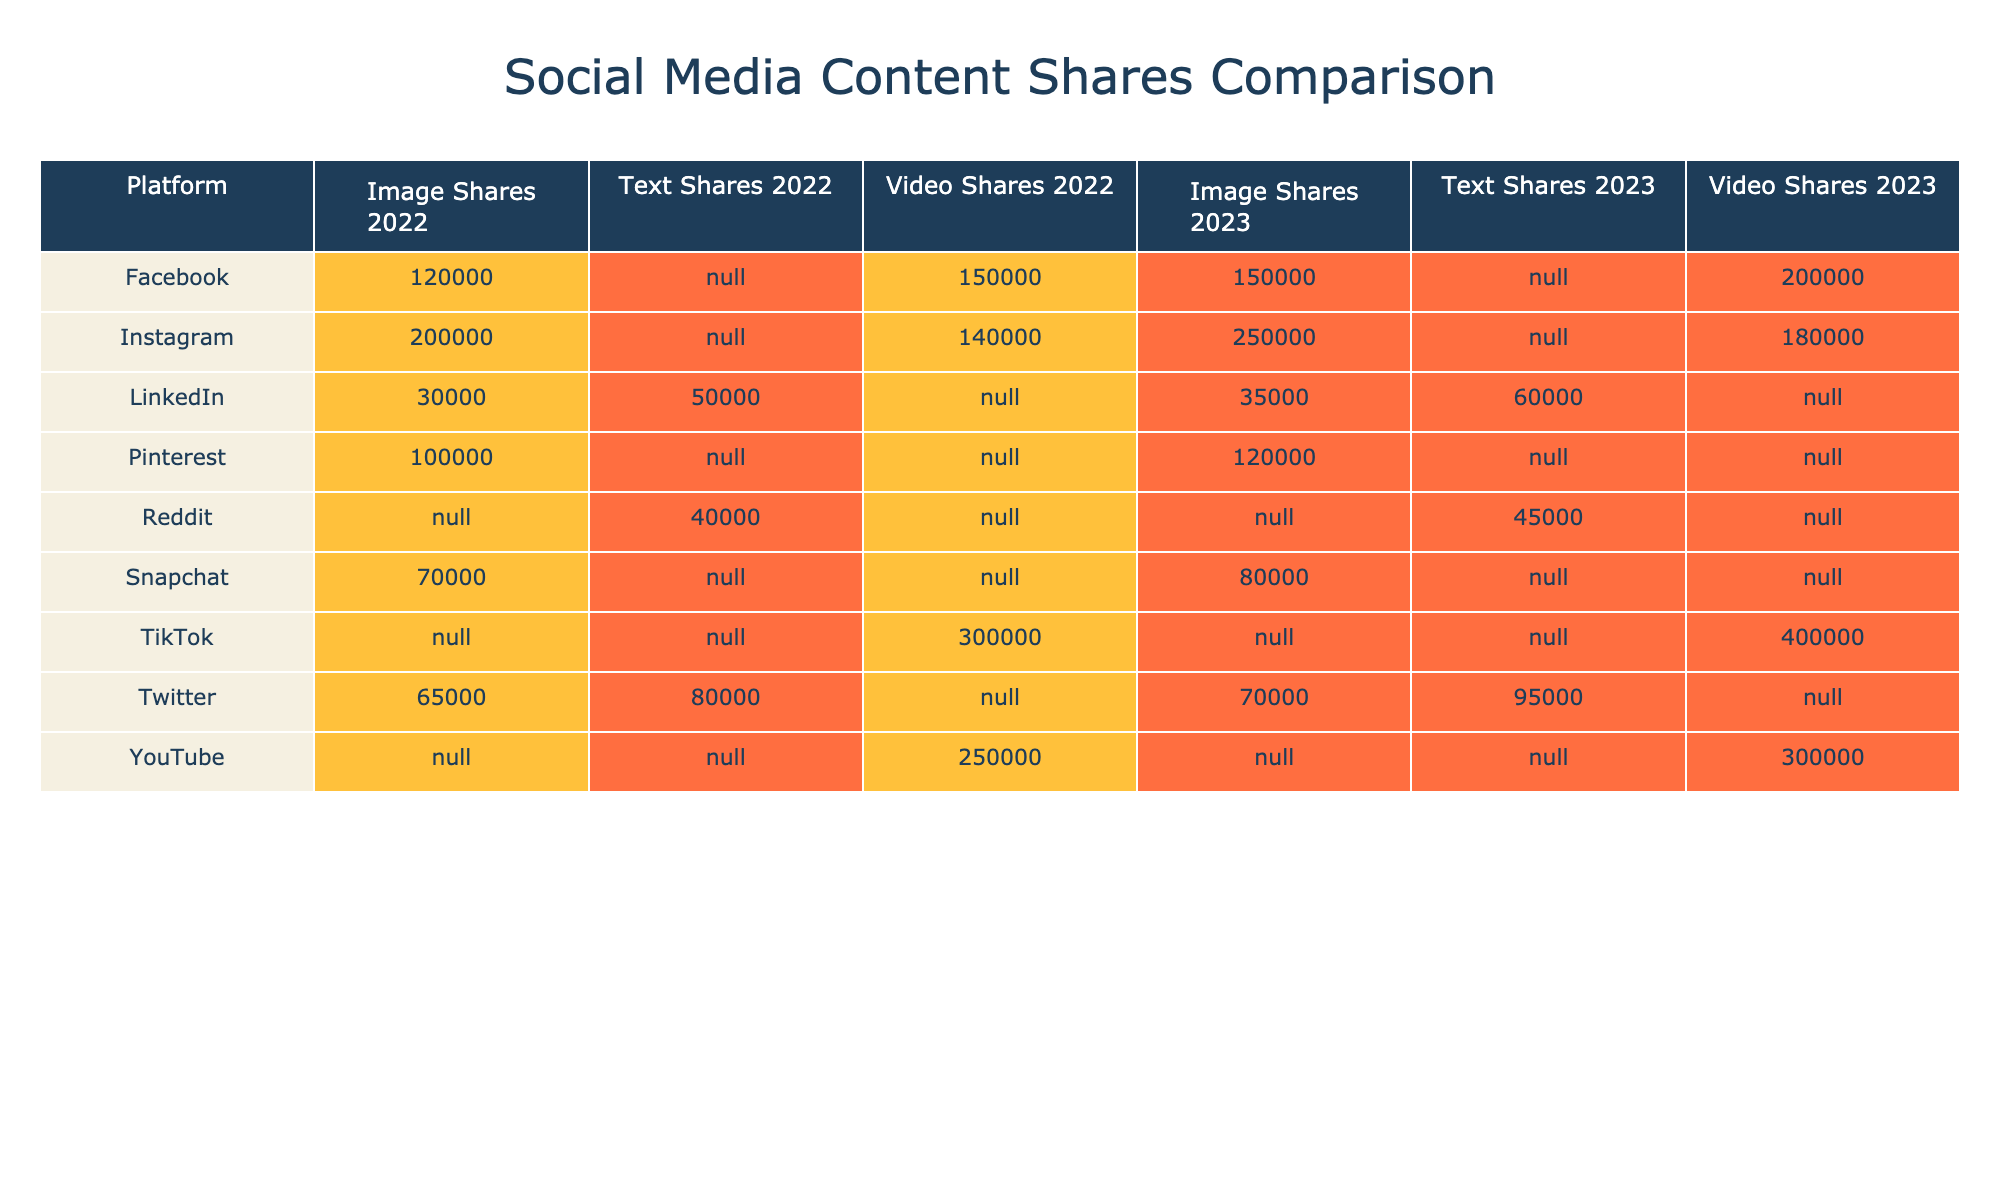What is the total number of video shares on TikTok in 2023? The table indicates that TikTok had 400,000 video shares in 2023, which is the only entry for video shares on that platform.
Answer: 400000 Which platform had the highest number of image shares in 2023? From the table, Instagram had 250,000 image shares in 2023, which is more than any other platform's image shares in that year.
Answer: Instagram What is the difference in the number of text shares between Twitter and LinkedIn in 2023? According to the table, Twitter had 95,000 text shares and LinkedIn had 60,000 text shares in 2023. The difference is 95,000 - 60,000 = 35,000.
Answer: 35000 Did the number of video shares on Facebook increase from 2022 to 2023? The table shows that Facebook had 150,000 video shares in 2022 and 200,000 in 2023. This indicates an increase.
Answer: Yes What is the average number of image shares for all platforms in 2023? To find the average, we sum the image shares for all platforms in 2023 (150000 + 70000 + 250000 + 35000 + 120000 + 80000 = 600000), then divide by the number of platforms with image shares (6). The average is 600000/6 = 100000.
Answer: 100000 What platform had the smallest increase in shares for image content from 2022 to 2023? By comparing the increases in image shares from 2022 to 2023, LinkedIn saw an increase of 5,000 (35,000 - 30,000), which is the smallest compared to other platforms.
Answer: LinkedIn How many shares did Snapchat have for image content in 2022? The table states that Snapchat had 70,000 image shares in 2022, which is directly taken from the corresponding row in the table.
Answer: 70000 Which content type on YouTube saw the highest number of shares in 2023? The table indicates that YouTube had 300,000 video shares in 2023. Video content is the only type listed for YouTube, hence it's the highest.
Answer: Video 